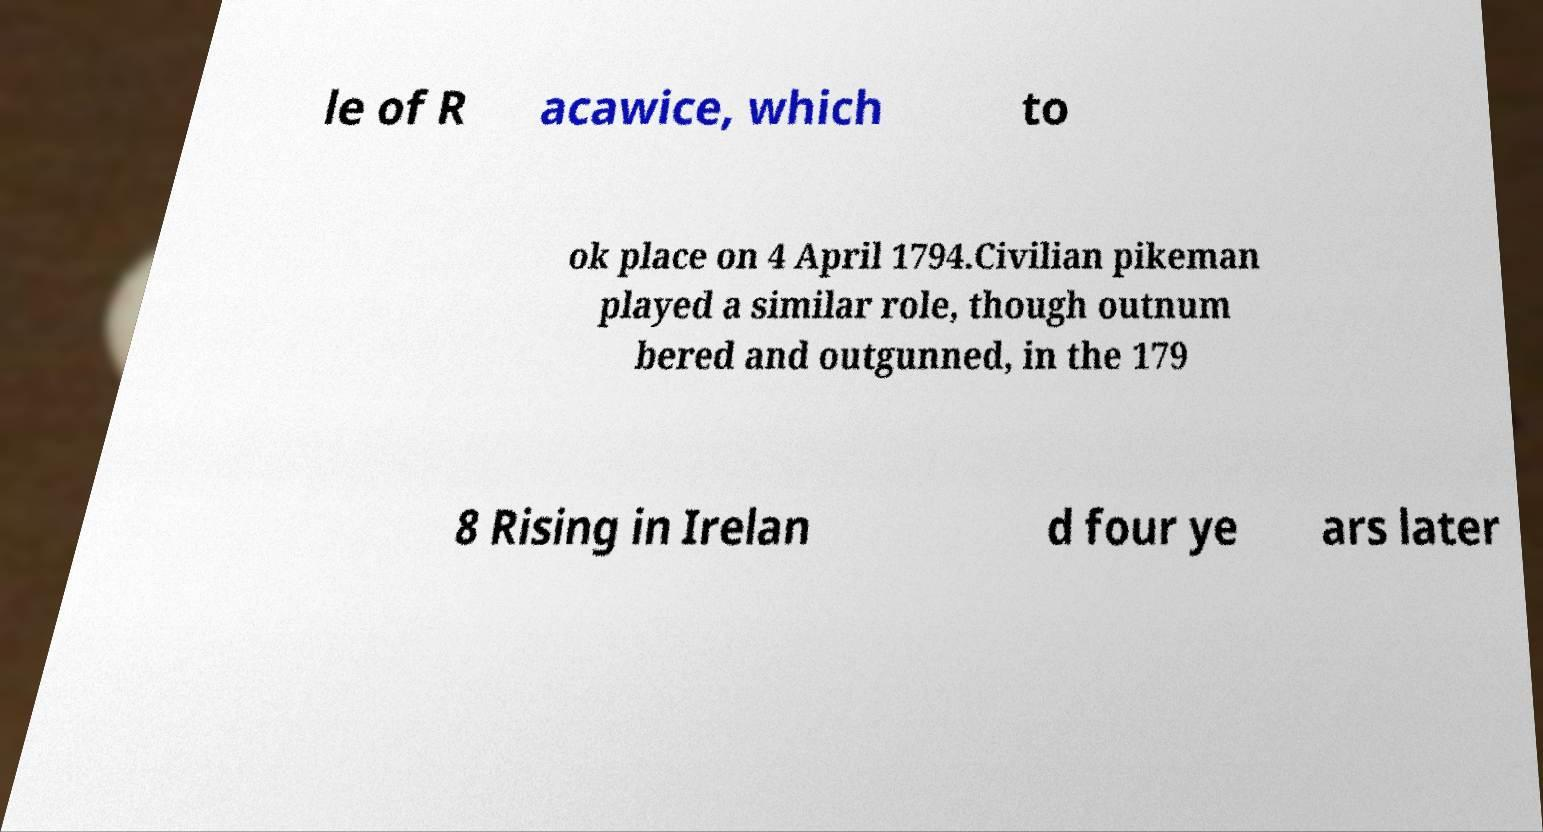Could you assist in decoding the text presented in this image and type it out clearly? le of R acawice, which to ok place on 4 April 1794.Civilian pikeman played a similar role, though outnum bered and outgunned, in the 179 8 Rising in Irelan d four ye ars later 